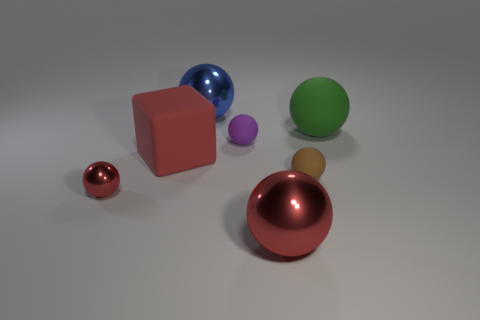Does the object that is behind the large green ball have the same color as the matte block? No, the object behind the large green ball does not share the same color as the matte block. The block appears to be a solid, matte pink color, while the object behind the green ball has a metallic, reflective red hue, which differentiates it from the matte texture and pink color of the block. 